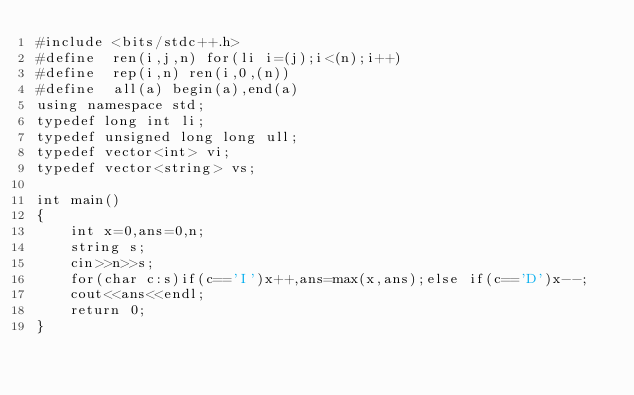Convert code to text. <code><loc_0><loc_0><loc_500><loc_500><_C++_>#include <bits/stdc++.h>
#define  ren(i,j,n) for(li i=(j);i<(n);i++)
#define  rep(i,n) ren(i,0,(n))
#define  all(a) begin(a),end(a)
using namespace std;
typedef long int li;
typedef unsigned long long ull;
typedef vector<int> vi;
typedef vector<string> vs;
 
int main()
{
    int x=0,ans=0,n;
    string s;
    cin>>n>>s;
    for(char c:s)if(c=='I')x++,ans=max(x,ans);else if(c=='D')x--;
    cout<<ans<<endl;
    return 0;
}</code> 